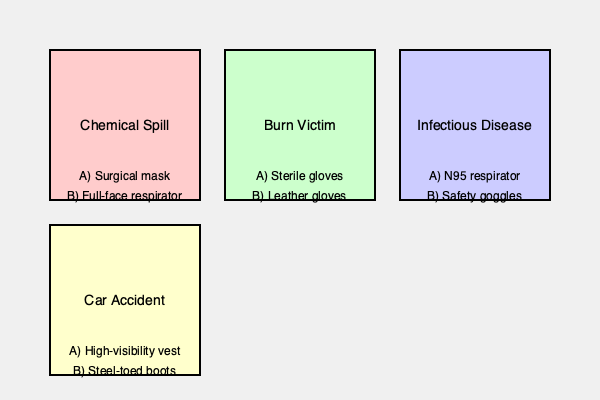Based on the illustrated emergency scenarios, identify the most appropriate personal protective equipment (PPE) for each situation. Which option (A or B) is the correct choice for each scenario? To identify the correct PPE for each emergency scenario, we need to consider the specific hazards associated with each situation:

1. Chemical Spill:
   - Hazard: Potentially harmful or toxic chemicals
   - Correct PPE: B) Full-face respirator
   - Explanation: A full-face respirator provides protection for both the respiratory system and eyes against chemical vapors and splashes.

2. Burn Victim:
   - Hazard: Risk of infection and contamination
   - Correct PPE: A) Sterile gloves
   - Explanation: Sterile gloves protect both the responder and the patient from potential infections, especially when dealing with open wounds.

3. Infectious Disease:
   - Hazard: Airborne pathogens
   - Correct PPE: A) N95 respirator
   - Explanation: N95 respirators filter out airborne particles, including many pathogens, providing protection against infectious diseases.

4. Car Accident:
   - Hazard: Traffic and low visibility conditions
   - Correct PPE: A) High-visibility vest
   - Explanation: A high-visibility vest increases the visibility of emergency responders, reducing the risk of being struck by vehicles at the accident scene.

While all the PPE options listed are important in various scenarios, the correct choices for these specific situations are the ones that address the primary hazard in each case.
Answer: 1-B, 2-A, 3-A, 4-A 